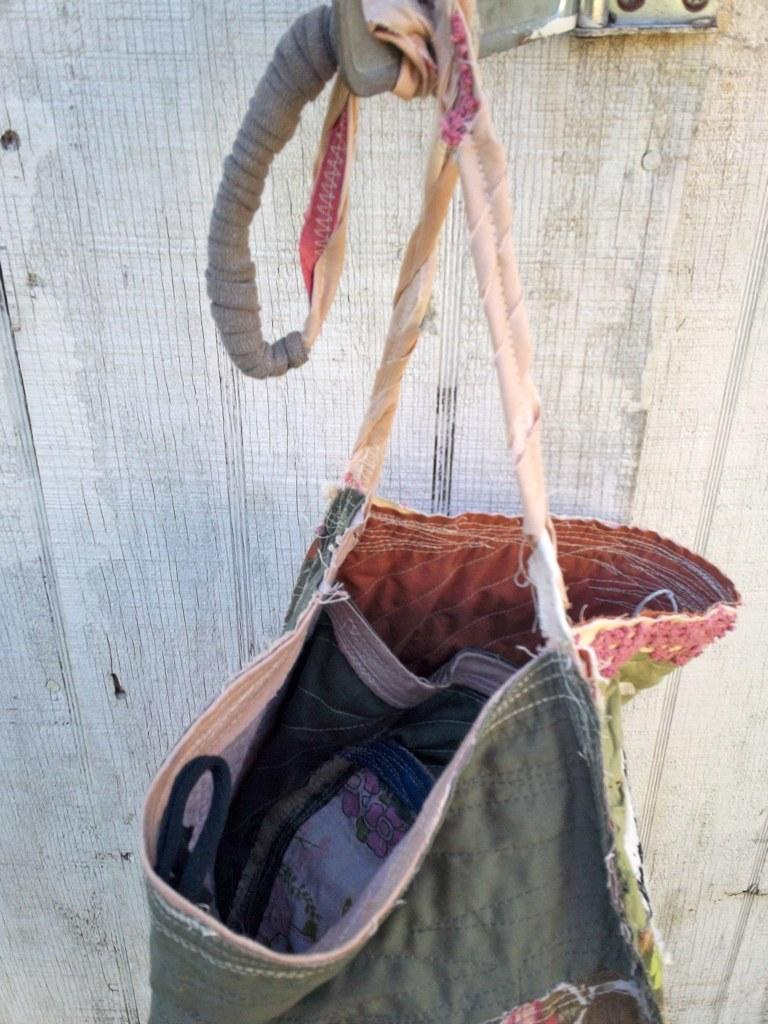What is the color of the bag in the image? The bag is gray in color. How is the bag positioned in the image? The bag is hanging on a clip of white color. What can be seen in the background of the image? There is a wall of white color in the background of the image. What type of brass instrument is being played in the image? There is no brass instrument or any indication of music being played in the image. 